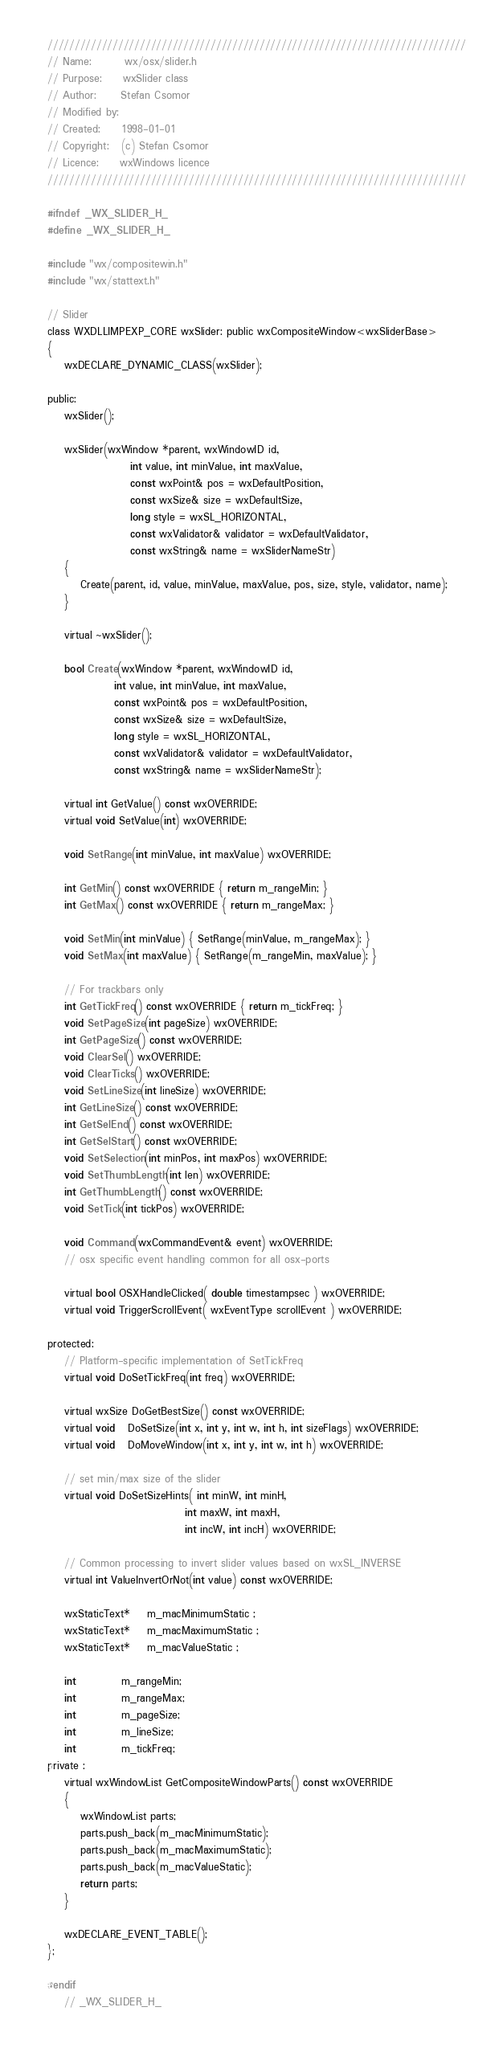Convert code to text. <code><loc_0><loc_0><loc_500><loc_500><_C_>/////////////////////////////////////////////////////////////////////////////
// Name:        wx/osx/slider.h
// Purpose:     wxSlider class
// Author:      Stefan Csomor
// Modified by:
// Created:     1998-01-01
// Copyright:   (c) Stefan Csomor
// Licence:     wxWindows licence
/////////////////////////////////////////////////////////////////////////////

#ifndef _WX_SLIDER_H_
#define _WX_SLIDER_H_

#include "wx/compositewin.h"
#include "wx/stattext.h"

// Slider
class WXDLLIMPEXP_CORE wxSlider: public wxCompositeWindow<wxSliderBase>
{
    wxDECLARE_DYNAMIC_CLASS(wxSlider);

public:
    wxSlider();

    wxSlider(wxWindow *parent, wxWindowID id,
                    int value, int minValue, int maxValue,
                    const wxPoint& pos = wxDefaultPosition,
                    const wxSize& size = wxDefaultSize,
                    long style = wxSL_HORIZONTAL,
                    const wxValidator& validator = wxDefaultValidator,
                    const wxString& name = wxSliderNameStr)
    {
        Create(parent, id, value, minValue, maxValue, pos, size, style, validator, name);
    }

    virtual ~wxSlider();

    bool Create(wxWindow *parent, wxWindowID id,
                int value, int minValue, int maxValue,
                const wxPoint& pos = wxDefaultPosition,
                const wxSize& size = wxDefaultSize,
                long style = wxSL_HORIZONTAL,
                const wxValidator& validator = wxDefaultValidator,
                const wxString& name = wxSliderNameStr);

    virtual int GetValue() const wxOVERRIDE;
    virtual void SetValue(int) wxOVERRIDE;

    void SetRange(int minValue, int maxValue) wxOVERRIDE;

    int GetMin() const wxOVERRIDE { return m_rangeMin; }
    int GetMax() const wxOVERRIDE { return m_rangeMax; }

    void SetMin(int minValue) { SetRange(minValue, m_rangeMax); }
    void SetMax(int maxValue) { SetRange(m_rangeMin, maxValue); }

    // For trackbars only
    int GetTickFreq() const wxOVERRIDE { return m_tickFreq; }
    void SetPageSize(int pageSize) wxOVERRIDE;
    int GetPageSize() const wxOVERRIDE;
    void ClearSel() wxOVERRIDE;
    void ClearTicks() wxOVERRIDE;
    void SetLineSize(int lineSize) wxOVERRIDE;
    int GetLineSize() const wxOVERRIDE;
    int GetSelEnd() const wxOVERRIDE;
    int GetSelStart() const wxOVERRIDE;
    void SetSelection(int minPos, int maxPos) wxOVERRIDE;
    void SetThumbLength(int len) wxOVERRIDE;
    int GetThumbLength() const wxOVERRIDE;
    void SetTick(int tickPos) wxOVERRIDE;

    void Command(wxCommandEvent& event) wxOVERRIDE;
    // osx specific event handling common for all osx-ports

    virtual bool OSXHandleClicked( double timestampsec ) wxOVERRIDE;
    virtual void TriggerScrollEvent( wxEventType scrollEvent ) wxOVERRIDE;

protected:
    // Platform-specific implementation of SetTickFreq
    virtual void DoSetTickFreq(int freq) wxOVERRIDE;

    virtual wxSize DoGetBestSize() const wxOVERRIDE;
    virtual void   DoSetSize(int x, int y, int w, int h, int sizeFlags) wxOVERRIDE;
    virtual void   DoMoveWindow(int x, int y, int w, int h) wxOVERRIDE;

    // set min/max size of the slider
    virtual void DoSetSizeHints( int minW, int minH,
                                 int maxW, int maxH,
                                 int incW, int incH) wxOVERRIDE;

    // Common processing to invert slider values based on wxSL_INVERSE
    virtual int ValueInvertOrNot(int value) const wxOVERRIDE;

    wxStaticText*    m_macMinimumStatic ;
    wxStaticText*    m_macMaximumStatic ;
    wxStaticText*    m_macValueStatic ;

    int           m_rangeMin;
    int           m_rangeMax;
    int           m_pageSize;
    int           m_lineSize;
    int           m_tickFreq;
private :
    virtual wxWindowList GetCompositeWindowParts() const wxOVERRIDE
    {
        wxWindowList parts;
        parts.push_back(m_macMinimumStatic);
        parts.push_back(m_macMaximumStatic);
        parts.push_back(m_macValueStatic);
        return parts;
    }

    wxDECLARE_EVENT_TABLE();
};

#endif
    // _WX_SLIDER_H_
</code> 